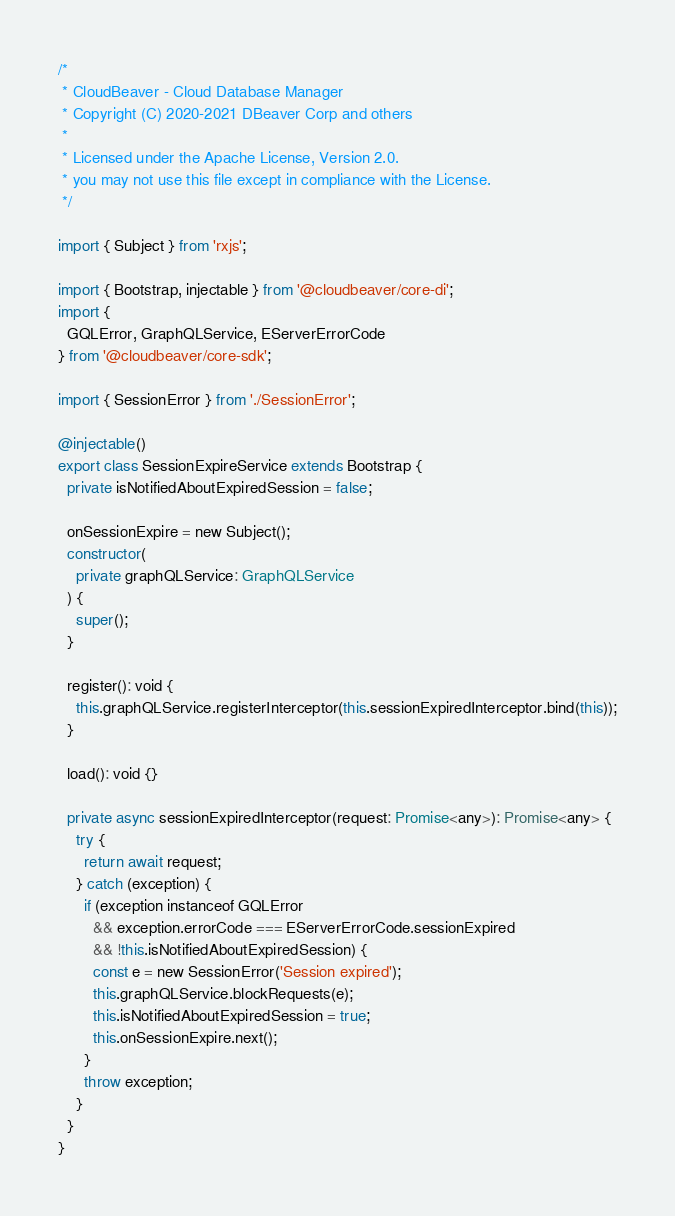<code> <loc_0><loc_0><loc_500><loc_500><_TypeScript_>/*
 * CloudBeaver - Cloud Database Manager
 * Copyright (C) 2020-2021 DBeaver Corp and others
 *
 * Licensed under the Apache License, Version 2.0.
 * you may not use this file except in compliance with the License.
 */

import { Subject } from 'rxjs';

import { Bootstrap, injectable } from '@cloudbeaver/core-di';
import {
  GQLError, GraphQLService, EServerErrorCode
} from '@cloudbeaver/core-sdk';

import { SessionError } from './SessionError';

@injectable()
export class SessionExpireService extends Bootstrap {
  private isNotifiedAboutExpiredSession = false;

  onSessionExpire = new Subject();
  constructor(
    private graphQLService: GraphQLService
  ) {
    super();
  }

  register(): void {
    this.graphQLService.registerInterceptor(this.sessionExpiredInterceptor.bind(this));
  }

  load(): void {}

  private async sessionExpiredInterceptor(request: Promise<any>): Promise<any> {
    try {
      return await request;
    } catch (exception) {
      if (exception instanceof GQLError
        && exception.errorCode === EServerErrorCode.sessionExpired
        && !this.isNotifiedAboutExpiredSession) {
        const e = new SessionError('Session expired');
        this.graphQLService.blockRequests(e);
        this.isNotifiedAboutExpiredSession = true;
        this.onSessionExpire.next();
      }
      throw exception;
    }
  }
}
</code> 